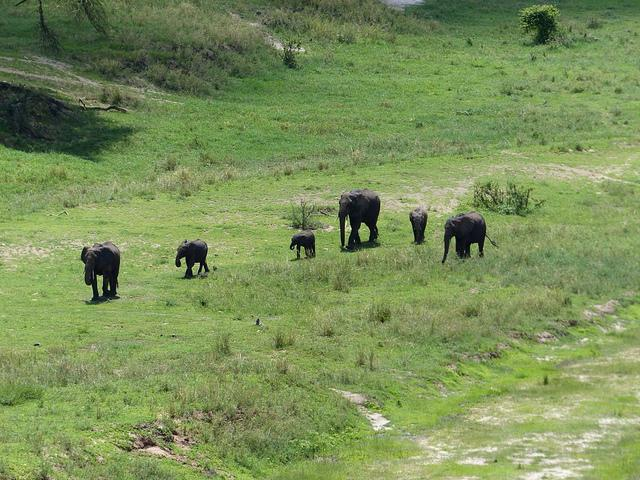Why might some of their trunks be curled?

Choices:
A) eating
B) drinking
C) avoid tripping
D) trumpeting eating 